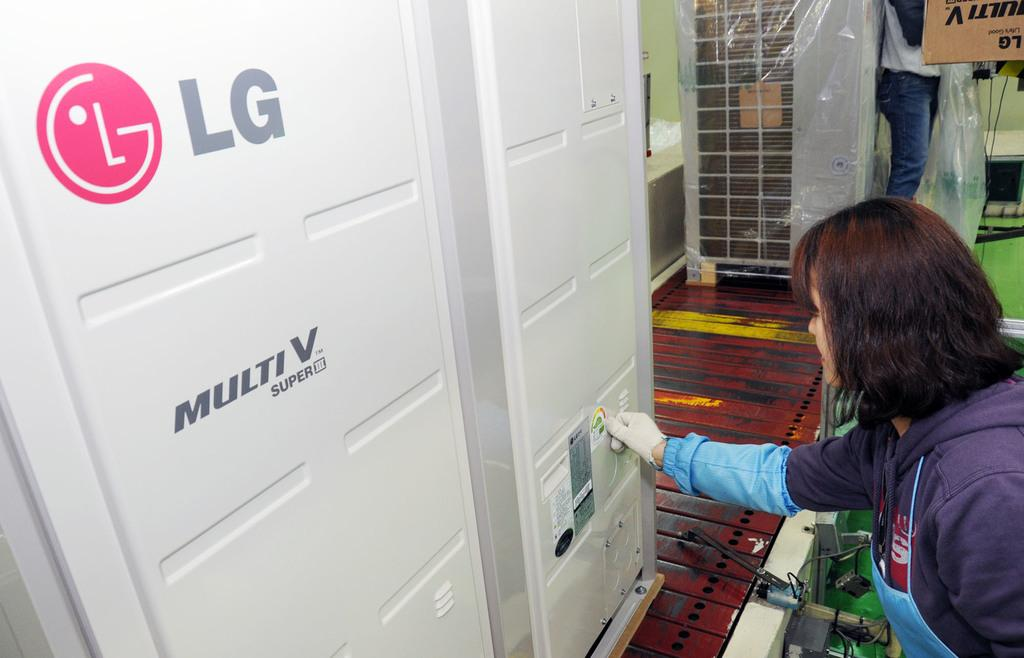Provide a one-sentence caption for the provided image. A woman is next to a machine, which bears the letters "LG". 